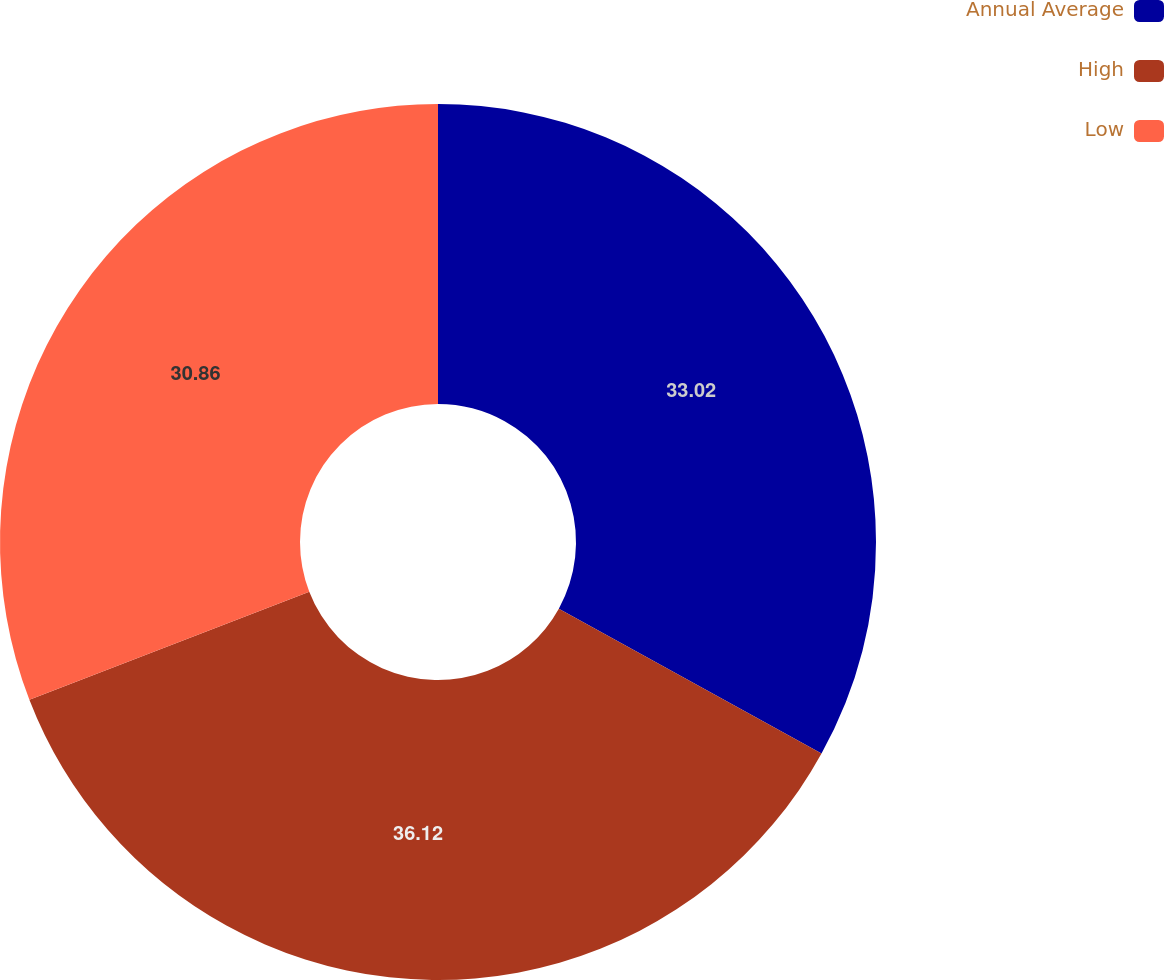Convert chart to OTSL. <chart><loc_0><loc_0><loc_500><loc_500><pie_chart><fcel>Annual Average<fcel>High<fcel>Low<nl><fcel>33.02%<fcel>36.11%<fcel>30.86%<nl></chart> 